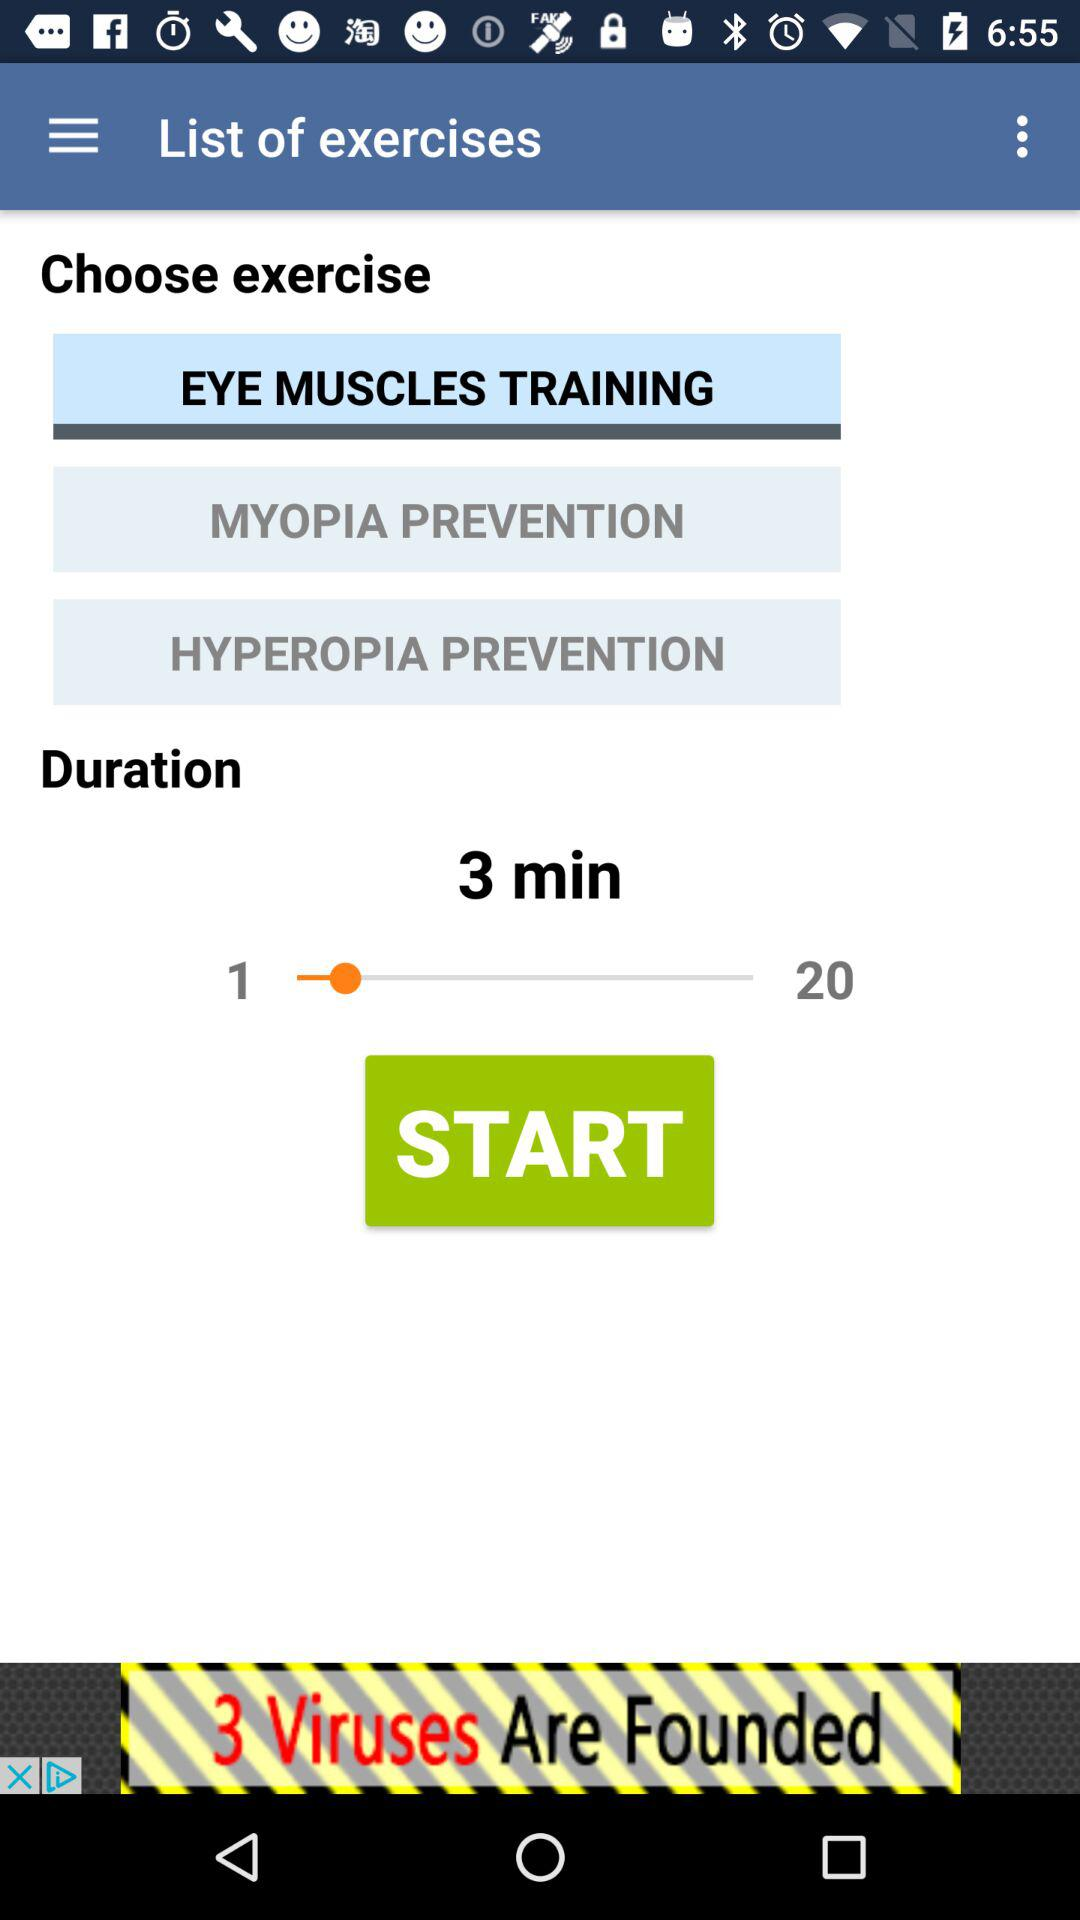What are the listed names of the different exercises? The listed names of the different exercises are "EYE MUSCLES TRAINING", "MYOPIA PREVENTION" and "HYPEROPIA PREVENTION". 